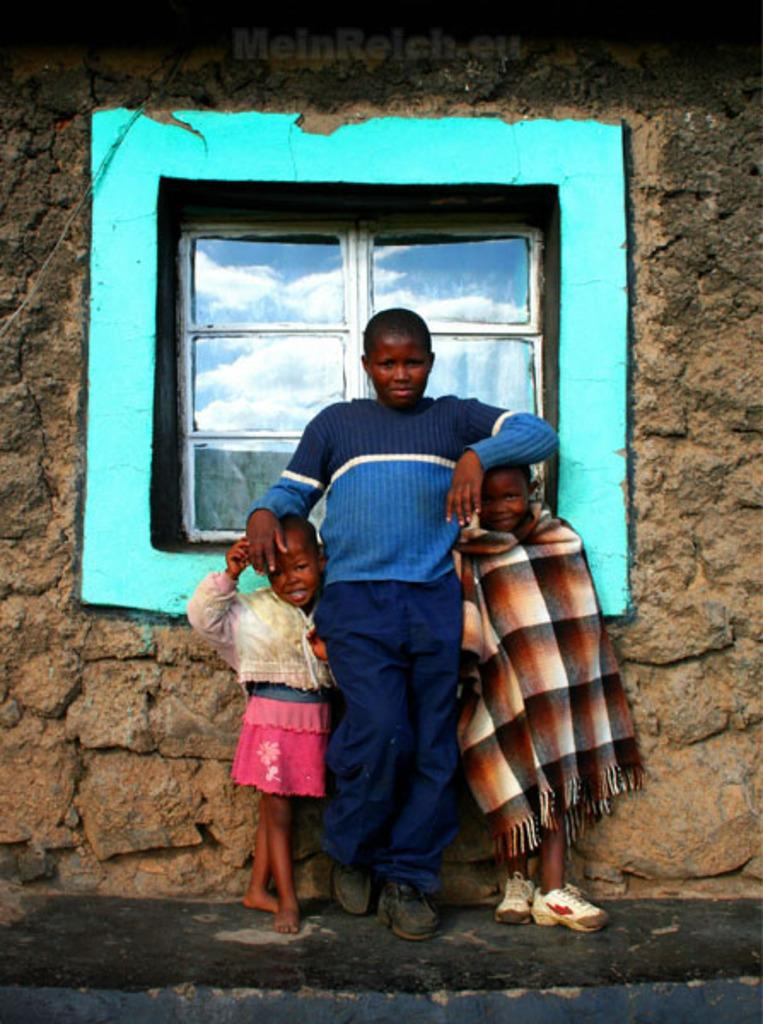How many people are in the image? There are three persons standing in the center of the image. What is the surface they are standing on? The persons are standing on the ground. What can be seen in the background of the image? There is a brick wall and a window in the background of the image. What type of cookware is being used for the discovery in the image? There is no cookware or discovery present in the image; it features three persons standing on the ground with a brick wall and a window in the background. 